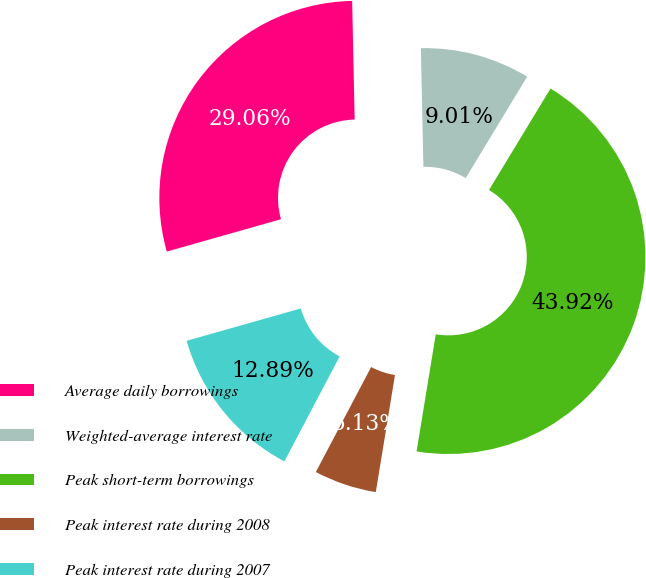<chart> <loc_0><loc_0><loc_500><loc_500><pie_chart><fcel>Average daily borrowings<fcel>Weighted-average interest rate<fcel>Peak short-term borrowings<fcel>Peak interest rate during 2008<fcel>Peak interest rate during 2007<nl><fcel>29.06%<fcel>9.01%<fcel>43.92%<fcel>5.13%<fcel>12.89%<nl></chart> 